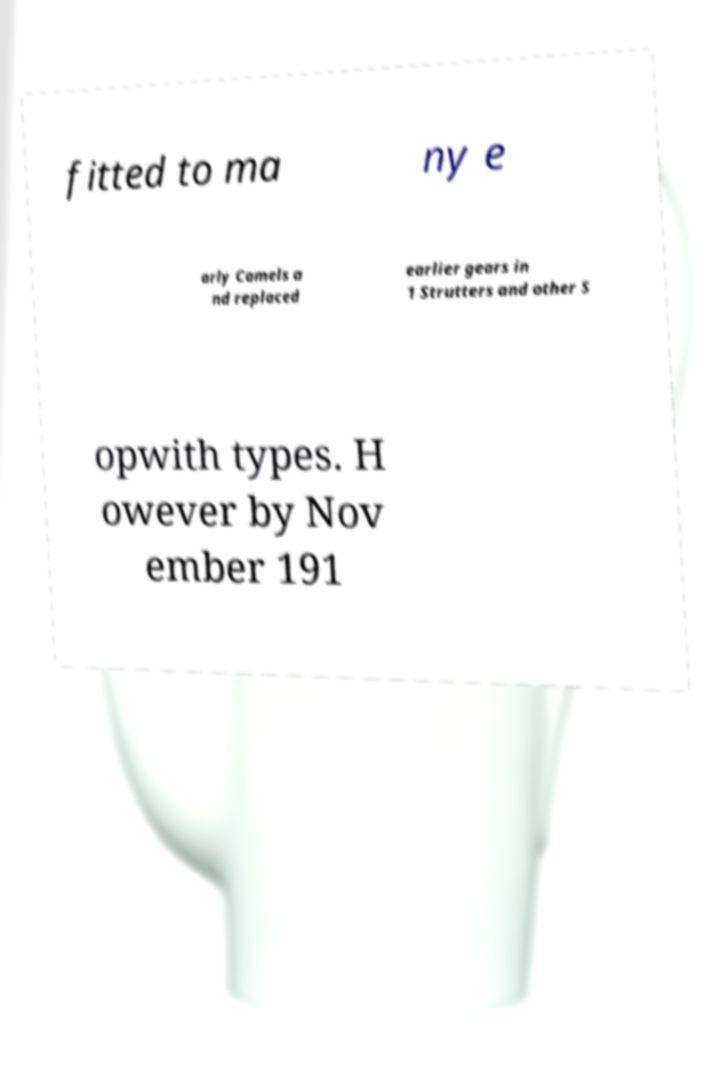Can you accurately transcribe the text from the provided image for me? fitted to ma ny e arly Camels a nd replaced earlier gears in 1 Strutters and other S opwith types. H owever by Nov ember 191 